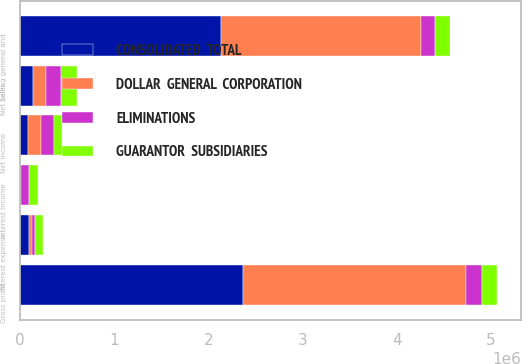Convert chart to OTSL. <chart><loc_0><loc_0><loc_500><loc_500><stacked_bar_chart><ecel><fcel>Net sales<fcel>Gross profit<fcel>Selling general and<fcel>Interest income<fcel>Interest expense<fcel>Net income<nl><fcel>ELIMINATIONS<fcel>165463<fcel>165463<fcel>149272<fcel>92598<fcel>26826<fcel>137943<nl><fcel>CONSOLIDATED  TOTAL<fcel>137943<fcel>2.3682e+06<fcel>2.13612e+06<fcel>2907<fcel>96592<fcel>86160<nl><fcel>GUARANTOR  SUBSIDIARIES<fcel>165463<fcel>165463<fcel>165463<fcel>88503<fcel>88503<fcel>86160<nl><fcel>DOLLAR  GENERAL  CORPORATION<fcel>137943<fcel>2.3682e+06<fcel>2.11993e+06<fcel>7002<fcel>34915<fcel>137943<nl></chart> 